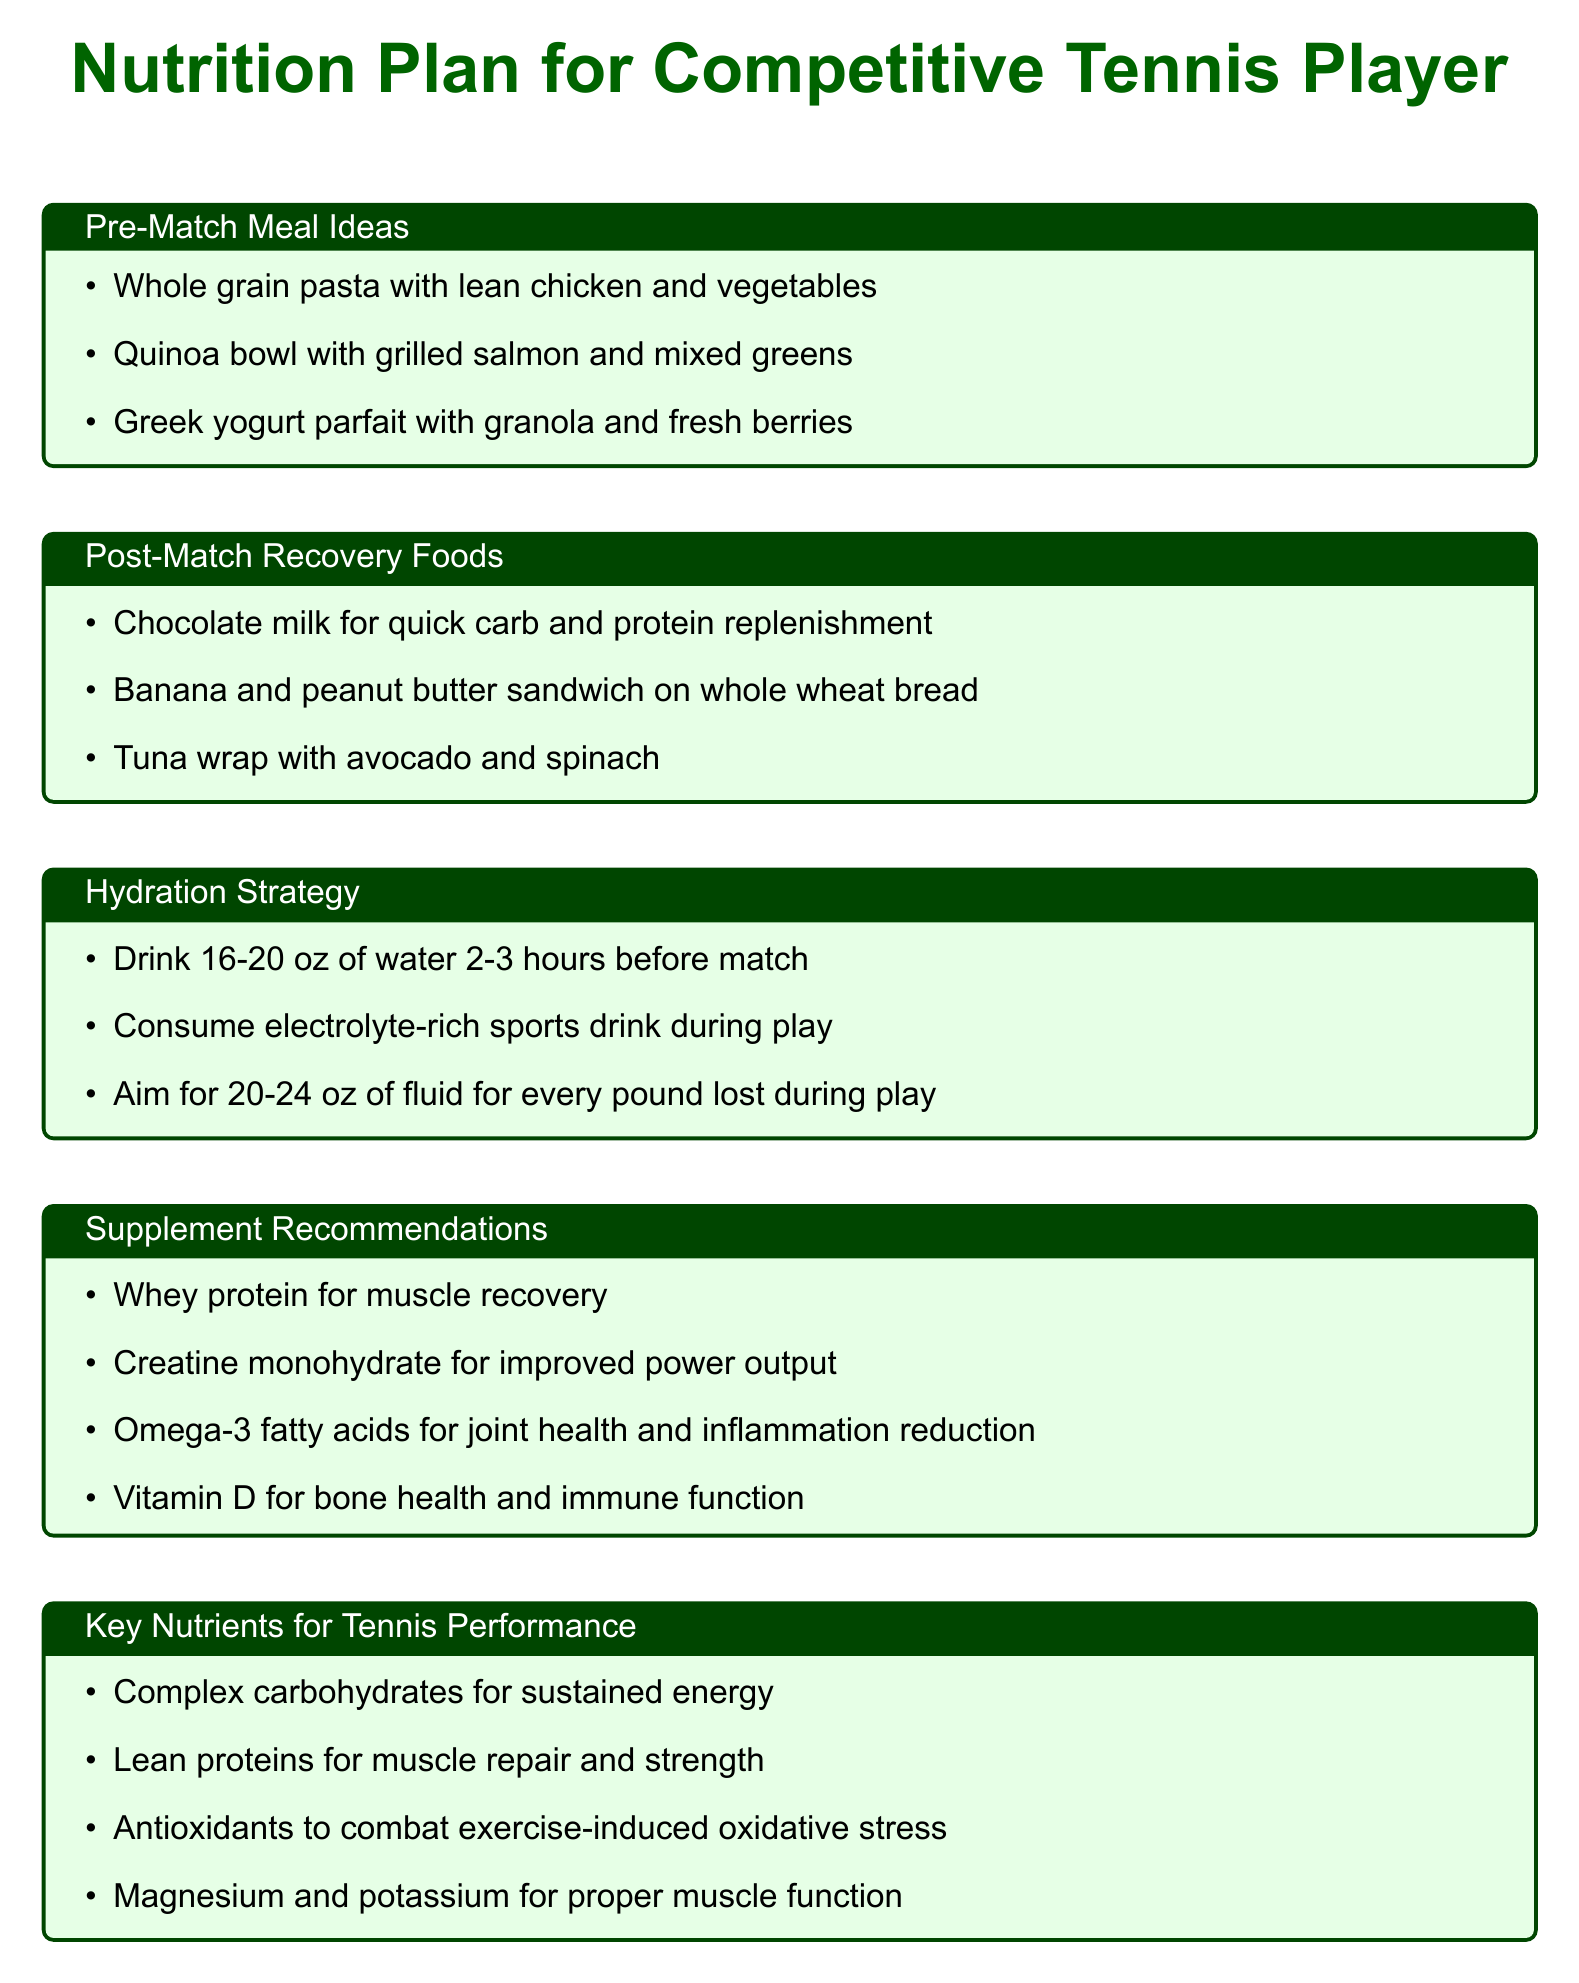What are three pre-match meal ideas? The document lists three pre-match meal ideas under the respective section.
Answer: Whole grain pasta with lean chicken and vegetables, Quinoa bowl with grilled salmon and mixed greens, Greek yogurt parfait with granola and fresh berries What should you drink 2-3 hours before a match? The hydration strategy section specifically mentions drinking water a few hours before a match.
Answer: 16-20 oz of water What recovery food contains chocolate? The document provides a specific post-match recovery food containing chocolate.
Answer: Chocolate milk Which supplement is recommended for muscle recovery? The supplement recommendations section indicates a specific supplement for muscle recovery.
Answer: Whey protein What nutrient is emphasized for sustained energy? The key nutrients section mentions a specific nutrient for sustained energy.
Answer: Complex carbohydrates How much fluid should be consumed for every pound lost during play? The hydration strategy section clarifies the amount of fluid to consume per pound lost during play.
Answer: 20-24 oz 